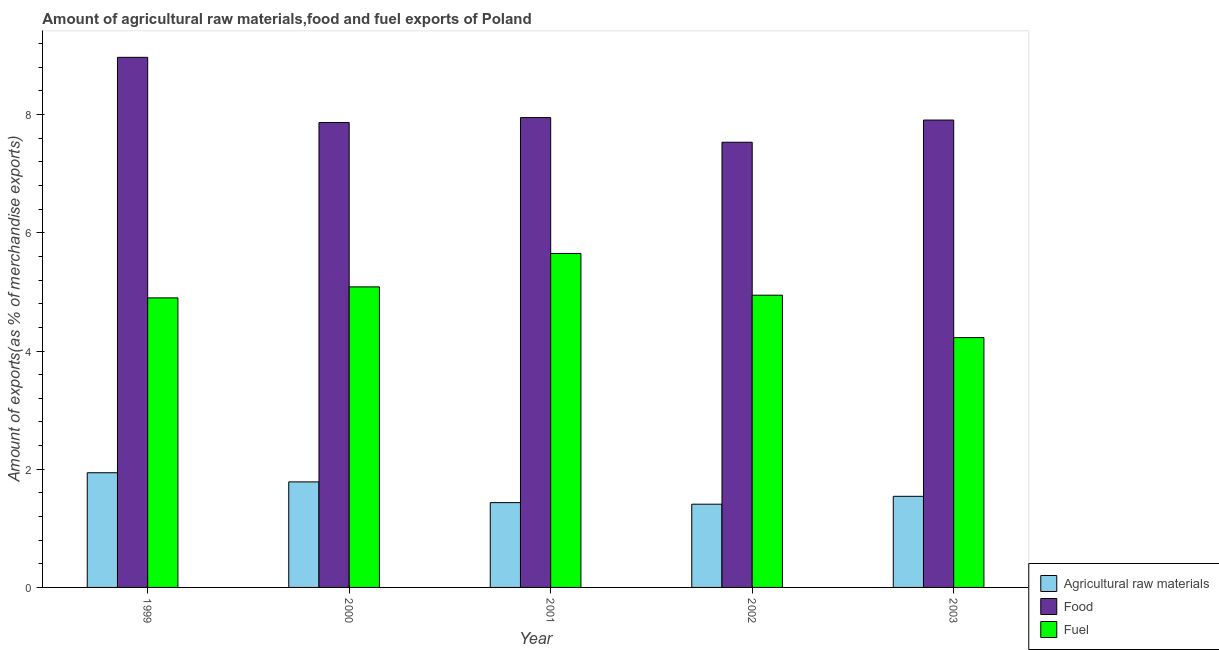How many different coloured bars are there?
Offer a terse response. 3. How many groups of bars are there?
Keep it short and to the point. 5. How many bars are there on the 3rd tick from the right?
Provide a succinct answer. 3. What is the label of the 5th group of bars from the left?
Provide a short and direct response. 2003. In how many cases, is the number of bars for a given year not equal to the number of legend labels?
Provide a succinct answer. 0. What is the percentage of fuel exports in 2000?
Give a very brief answer. 5.09. Across all years, what is the maximum percentage of fuel exports?
Keep it short and to the point. 5.65. Across all years, what is the minimum percentage of food exports?
Ensure brevity in your answer.  7.53. In which year was the percentage of raw materials exports minimum?
Provide a short and direct response. 2002. What is the total percentage of raw materials exports in the graph?
Make the answer very short. 8.11. What is the difference between the percentage of raw materials exports in 1999 and that in 2003?
Your response must be concise. 0.4. What is the difference between the percentage of raw materials exports in 1999 and the percentage of fuel exports in 2003?
Your answer should be compact. 0.4. What is the average percentage of raw materials exports per year?
Keep it short and to the point. 1.62. In the year 2003, what is the difference between the percentage of raw materials exports and percentage of fuel exports?
Your answer should be very brief. 0. In how many years, is the percentage of raw materials exports greater than 0.8 %?
Make the answer very short. 5. What is the ratio of the percentage of raw materials exports in 2001 to that in 2003?
Keep it short and to the point. 0.93. What is the difference between the highest and the second highest percentage of raw materials exports?
Offer a terse response. 0.15. What is the difference between the highest and the lowest percentage of raw materials exports?
Provide a succinct answer. 0.53. Is the sum of the percentage of raw materials exports in 2000 and 2003 greater than the maximum percentage of food exports across all years?
Your answer should be very brief. Yes. What does the 3rd bar from the left in 2000 represents?
Provide a short and direct response. Fuel. What does the 2nd bar from the right in 2002 represents?
Your answer should be compact. Food. Is it the case that in every year, the sum of the percentage of raw materials exports and percentage of food exports is greater than the percentage of fuel exports?
Your answer should be very brief. Yes. How many bars are there?
Give a very brief answer. 15. Does the graph contain grids?
Keep it short and to the point. No. How many legend labels are there?
Your answer should be compact. 3. What is the title of the graph?
Provide a short and direct response. Amount of agricultural raw materials,food and fuel exports of Poland. Does "Capital account" appear as one of the legend labels in the graph?
Keep it short and to the point. No. What is the label or title of the Y-axis?
Offer a terse response. Amount of exports(as % of merchandise exports). What is the Amount of exports(as % of merchandise exports) in Agricultural raw materials in 1999?
Your response must be concise. 1.94. What is the Amount of exports(as % of merchandise exports) of Food in 1999?
Provide a succinct answer. 8.97. What is the Amount of exports(as % of merchandise exports) of Fuel in 1999?
Keep it short and to the point. 4.9. What is the Amount of exports(as % of merchandise exports) in Agricultural raw materials in 2000?
Ensure brevity in your answer.  1.79. What is the Amount of exports(as % of merchandise exports) of Food in 2000?
Give a very brief answer. 7.87. What is the Amount of exports(as % of merchandise exports) in Fuel in 2000?
Offer a terse response. 5.09. What is the Amount of exports(as % of merchandise exports) of Agricultural raw materials in 2001?
Provide a succinct answer. 1.43. What is the Amount of exports(as % of merchandise exports) of Food in 2001?
Your answer should be compact. 7.95. What is the Amount of exports(as % of merchandise exports) of Fuel in 2001?
Ensure brevity in your answer.  5.65. What is the Amount of exports(as % of merchandise exports) of Agricultural raw materials in 2002?
Your answer should be compact. 1.41. What is the Amount of exports(as % of merchandise exports) in Food in 2002?
Your answer should be compact. 7.53. What is the Amount of exports(as % of merchandise exports) in Fuel in 2002?
Your answer should be very brief. 4.94. What is the Amount of exports(as % of merchandise exports) in Agricultural raw materials in 2003?
Offer a very short reply. 1.54. What is the Amount of exports(as % of merchandise exports) in Food in 2003?
Offer a very short reply. 7.91. What is the Amount of exports(as % of merchandise exports) in Fuel in 2003?
Keep it short and to the point. 4.23. Across all years, what is the maximum Amount of exports(as % of merchandise exports) in Agricultural raw materials?
Keep it short and to the point. 1.94. Across all years, what is the maximum Amount of exports(as % of merchandise exports) in Food?
Make the answer very short. 8.97. Across all years, what is the maximum Amount of exports(as % of merchandise exports) of Fuel?
Offer a terse response. 5.65. Across all years, what is the minimum Amount of exports(as % of merchandise exports) in Agricultural raw materials?
Offer a very short reply. 1.41. Across all years, what is the minimum Amount of exports(as % of merchandise exports) of Food?
Provide a short and direct response. 7.53. Across all years, what is the minimum Amount of exports(as % of merchandise exports) in Fuel?
Provide a short and direct response. 4.23. What is the total Amount of exports(as % of merchandise exports) in Agricultural raw materials in the graph?
Keep it short and to the point. 8.11. What is the total Amount of exports(as % of merchandise exports) of Food in the graph?
Give a very brief answer. 40.22. What is the total Amount of exports(as % of merchandise exports) in Fuel in the graph?
Make the answer very short. 24.81. What is the difference between the Amount of exports(as % of merchandise exports) of Agricultural raw materials in 1999 and that in 2000?
Provide a short and direct response. 0.15. What is the difference between the Amount of exports(as % of merchandise exports) in Food in 1999 and that in 2000?
Offer a terse response. 1.1. What is the difference between the Amount of exports(as % of merchandise exports) of Fuel in 1999 and that in 2000?
Provide a succinct answer. -0.19. What is the difference between the Amount of exports(as % of merchandise exports) in Agricultural raw materials in 1999 and that in 2001?
Your answer should be compact. 0.51. What is the difference between the Amount of exports(as % of merchandise exports) of Food in 1999 and that in 2001?
Keep it short and to the point. 1.02. What is the difference between the Amount of exports(as % of merchandise exports) in Fuel in 1999 and that in 2001?
Ensure brevity in your answer.  -0.75. What is the difference between the Amount of exports(as % of merchandise exports) in Agricultural raw materials in 1999 and that in 2002?
Ensure brevity in your answer.  0.53. What is the difference between the Amount of exports(as % of merchandise exports) in Food in 1999 and that in 2002?
Your answer should be very brief. 1.44. What is the difference between the Amount of exports(as % of merchandise exports) of Fuel in 1999 and that in 2002?
Give a very brief answer. -0.05. What is the difference between the Amount of exports(as % of merchandise exports) in Agricultural raw materials in 1999 and that in 2003?
Offer a terse response. 0.4. What is the difference between the Amount of exports(as % of merchandise exports) of Food in 1999 and that in 2003?
Keep it short and to the point. 1.06. What is the difference between the Amount of exports(as % of merchandise exports) in Fuel in 1999 and that in 2003?
Your answer should be compact. 0.67. What is the difference between the Amount of exports(as % of merchandise exports) of Agricultural raw materials in 2000 and that in 2001?
Your response must be concise. 0.35. What is the difference between the Amount of exports(as % of merchandise exports) of Food in 2000 and that in 2001?
Your response must be concise. -0.08. What is the difference between the Amount of exports(as % of merchandise exports) of Fuel in 2000 and that in 2001?
Provide a short and direct response. -0.57. What is the difference between the Amount of exports(as % of merchandise exports) of Agricultural raw materials in 2000 and that in 2002?
Keep it short and to the point. 0.38. What is the difference between the Amount of exports(as % of merchandise exports) of Food in 2000 and that in 2002?
Offer a terse response. 0.33. What is the difference between the Amount of exports(as % of merchandise exports) in Fuel in 2000 and that in 2002?
Offer a very short reply. 0.14. What is the difference between the Amount of exports(as % of merchandise exports) in Agricultural raw materials in 2000 and that in 2003?
Offer a very short reply. 0.24. What is the difference between the Amount of exports(as % of merchandise exports) of Food in 2000 and that in 2003?
Your answer should be compact. -0.04. What is the difference between the Amount of exports(as % of merchandise exports) in Fuel in 2000 and that in 2003?
Provide a short and direct response. 0.86. What is the difference between the Amount of exports(as % of merchandise exports) in Agricultural raw materials in 2001 and that in 2002?
Offer a very short reply. 0.03. What is the difference between the Amount of exports(as % of merchandise exports) of Food in 2001 and that in 2002?
Give a very brief answer. 0.42. What is the difference between the Amount of exports(as % of merchandise exports) in Fuel in 2001 and that in 2002?
Your answer should be very brief. 0.71. What is the difference between the Amount of exports(as % of merchandise exports) in Agricultural raw materials in 2001 and that in 2003?
Your answer should be very brief. -0.11. What is the difference between the Amount of exports(as % of merchandise exports) of Food in 2001 and that in 2003?
Your answer should be compact. 0.04. What is the difference between the Amount of exports(as % of merchandise exports) in Fuel in 2001 and that in 2003?
Ensure brevity in your answer.  1.42. What is the difference between the Amount of exports(as % of merchandise exports) of Agricultural raw materials in 2002 and that in 2003?
Offer a very short reply. -0.13. What is the difference between the Amount of exports(as % of merchandise exports) in Food in 2002 and that in 2003?
Your answer should be compact. -0.38. What is the difference between the Amount of exports(as % of merchandise exports) in Fuel in 2002 and that in 2003?
Your response must be concise. 0.72. What is the difference between the Amount of exports(as % of merchandise exports) in Agricultural raw materials in 1999 and the Amount of exports(as % of merchandise exports) in Food in 2000?
Keep it short and to the point. -5.93. What is the difference between the Amount of exports(as % of merchandise exports) in Agricultural raw materials in 1999 and the Amount of exports(as % of merchandise exports) in Fuel in 2000?
Offer a very short reply. -3.14. What is the difference between the Amount of exports(as % of merchandise exports) in Food in 1999 and the Amount of exports(as % of merchandise exports) in Fuel in 2000?
Give a very brief answer. 3.88. What is the difference between the Amount of exports(as % of merchandise exports) in Agricultural raw materials in 1999 and the Amount of exports(as % of merchandise exports) in Food in 2001?
Ensure brevity in your answer.  -6.01. What is the difference between the Amount of exports(as % of merchandise exports) of Agricultural raw materials in 1999 and the Amount of exports(as % of merchandise exports) of Fuel in 2001?
Offer a terse response. -3.71. What is the difference between the Amount of exports(as % of merchandise exports) of Food in 1999 and the Amount of exports(as % of merchandise exports) of Fuel in 2001?
Make the answer very short. 3.32. What is the difference between the Amount of exports(as % of merchandise exports) in Agricultural raw materials in 1999 and the Amount of exports(as % of merchandise exports) in Food in 2002?
Ensure brevity in your answer.  -5.59. What is the difference between the Amount of exports(as % of merchandise exports) in Agricultural raw materials in 1999 and the Amount of exports(as % of merchandise exports) in Fuel in 2002?
Your answer should be very brief. -3. What is the difference between the Amount of exports(as % of merchandise exports) of Food in 1999 and the Amount of exports(as % of merchandise exports) of Fuel in 2002?
Offer a terse response. 4.02. What is the difference between the Amount of exports(as % of merchandise exports) in Agricultural raw materials in 1999 and the Amount of exports(as % of merchandise exports) in Food in 2003?
Keep it short and to the point. -5.97. What is the difference between the Amount of exports(as % of merchandise exports) of Agricultural raw materials in 1999 and the Amount of exports(as % of merchandise exports) of Fuel in 2003?
Ensure brevity in your answer.  -2.29. What is the difference between the Amount of exports(as % of merchandise exports) of Food in 1999 and the Amount of exports(as % of merchandise exports) of Fuel in 2003?
Offer a very short reply. 4.74. What is the difference between the Amount of exports(as % of merchandise exports) of Agricultural raw materials in 2000 and the Amount of exports(as % of merchandise exports) of Food in 2001?
Ensure brevity in your answer.  -6.16. What is the difference between the Amount of exports(as % of merchandise exports) of Agricultural raw materials in 2000 and the Amount of exports(as % of merchandise exports) of Fuel in 2001?
Make the answer very short. -3.87. What is the difference between the Amount of exports(as % of merchandise exports) of Food in 2000 and the Amount of exports(as % of merchandise exports) of Fuel in 2001?
Provide a succinct answer. 2.21. What is the difference between the Amount of exports(as % of merchandise exports) of Agricultural raw materials in 2000 and the Amount of exports(as % of merchandise exports) of Food in 2002?
Offer a terse response. -5.75. What is the difference between the Amount of exports(as % of merchandise exports) in Agricultural raw materials in 2000 and the Amount of exports(as % of merchandise exports) in Fuel in 2002?
Your answer should be very brief. -3.16. What is the difference between the Amount of exports(as % of merchandise exports) of Food in 2000 and the Amount of exports(as % of merchandise exports) of Fuel in 2002?
Provide a succinct answer. 2.92. What is the difference between the Amount of exports(as % of merchandise exports) of Agricultural raw materials in 2000 and the Amount of exports(as % of merchandise exports) of Food in 2003?
Give a very brief answer. -6.12. What is the difference between the Amount of exports(as % of merchandise exports) in Agricultural raw materials in 2000 and the Amount of exports(as % of merchandise exports) in Fuel in 2003?
Your answer should be very brief. -2.44. What is the difference between the Amount of exports(as % of merchandise exports) of Food in 2000 and the Amount of exports(as % of merchandise exports) of Fuel in 2003?
Your answer should be compact. 3.64. What is the difference between the Amount of exports(as % of merchandise exports) of Agricultural raw materials in 2001 and the Amount of exports(as % of merchandise exports) of Food in 2002?
Offer a very short reply. -6.1. What is the difference between the Amount of exports(as % of merchandise exports) in Agricultural raw materials in 2001 and the Amount of exports(as % of merchandise exports) in Fuel in 2002?
Ensure brevity in your answer.  -3.51. What is the difference between the Amount of exports(as % of merchandise exports) of Food in 2001 and the Amount of exports(as % of merchandise exports) of Fuel in 2002?
Give a very brief answer. 3. What is the difference between the Amount of exports(as % of merchandise exports) in Agricultural raw materials in 2001 and the Amount of exports(as % of merchandise exports) in Food in 2003?
Make the answer very short. -6.47. What is the difference between the Amount of exports(as % of merchandise exports) of Agricultural raw materials in 2001 and the Amount of exports(as % of merchandise exports) of Fuel in 2003?
Your answer should be very brief. -2.79. What is the difference between the Amount of exports(as % of merchandise exports) of Food in 2001 and the Amount of exports(as % of merchandise exports) of Fuel in 2003?
Provide a succinct answer. 3.72. What is the difference between the Amount of exports(as % of merchandise exports) of Agricultural raw materials in 2002 and the Amount of exports(as % of merchandise exports) of Food in 2003?
Ensure brevity in your answer.  -6.5. What is the difference between the Amount of exports(as % of merchandise exports) in Agricultural raw materials in 2002 and the Amount of exports(as % of merchandise exports) in Fuel in 2003?
Offer a very short reply. -2.82. What is the difference between the Amount of exports(as % of merchandise exports) in Food in 2002 and the Amount of exports(as % of merchandise exports) in Fuel in 2003?
Give a very brief answer. 3.31. What is the average Amount of exports(as % of merchandise exports) of Agricultural raw materials per year?
Provide a succinct answer. 1.62. What is the average Amount of exports(as % of merchandise exports) in Food per year?
Your answer should be very brief. 8.04. What is the average Amount of exports(as % of merchandise exports) of Fuel per year?
Make the answer very short. 4.96. In the year 1999, what is the difference between the Amount of exports(as % of merchandise exports) in Agricultural raw materials and Amount of exports(as % of merchandise exports) in Food?
Provide a succinct answer. -7.03. In the year 1999, what is the difference between the Amount of exports(as % of merchandise exports) in Agricultural raw materials and Amount of exports(as % of merchandise exports) in Fuel?
Ensure brevity in your answer.  -2.96. In the year 1999, what is the difference between the Amount of exports(as % of merchandise exports) in Food and Amount of exports(as % of merchandise exports) in Fuel?
Keep it short and to the point. 4.07. In the year 2000, what is the difference between the Amount of exports(as % of merchandise exports) of Agricultural raw materials and Amount of exports(as % of merchandise exports) of Food?
Make the answer very short. -6.08. In the year 2000, what is the difference between the Amount of exports(as % of merchandise exports) of Agricultural raw materials and Amount of exports(as % of merchandise exports) of Fuel?
Provide a succinct answer. -3.3. In the year 2000, what is the difference between the Amount of exports(as % of merchandise exports) in Food and Amount of exports(as % of merchandise exports) in Fuel?
Your answer should be very brief. 2.78. In the year 2001, what is the difference between the Amount of exports(as % of merchandise exports) in Agricultural raw materials and Amount of exports(as % of merchandise exports) in Food?
Make the answer very short. -6.51. In the year 2001, what is the difference between the Amount of exports(as % of merchandise exports) of Agricultural raw materials and Amount of exports(as % of merchandise exports) of Fuel?
Your answer should be compact. -4.22. In the year 2001, what is the difference between the Amount of exports(as % of merchandise exports) of Food and Amount of exports(as % of merchandise exports) of Fuel?
Give a very brief answer. 2.3. In the year 2002, what is the difference between the Amount of exports(as % of merchandise exports) in Agricultural raw materials and Amount of exports(as % of merchandise exports) in Food?
Ensure brevity in your answer.  -6.12. In the year 2002, what is the difference between the Amount of exports(as % of merchandise exports) in Agricultural raw materials and Amount of exports(as % of merchandise exports) in Fuel?
Provide a short and direct response. -3.54. In the year 2002, what is the difference between the Amount of exports(as % of merchandise exports) in Food and Amount of exports(as % of merchandise exports) in Fuel?
Your answer should be very brief. 2.59. In the year 2003, what is the difference between the Amount of exports(as % of merchandise exports) in Agricultural raw materials and Amount of exports(as % of merchandise exports) in Food?
Your answer should be very brief. -6.37. In the year 2003, what is the difference between the Amount of exports(as % of merchandise exports) of Agricultural raw materials and Amount of exports(as % of merchandise exports) of Fuel?
Offer a very short reply. -2.69. In the year 2003, what is the difference between the Amount of exports(as % of merchandise exports) in Food and Amount of exports(as % of merchandise exports) in Fuel?
Offer a terse response. 3.68. What is the ratio of the Amount of exports(as % of merchandise exports) of Agricultural raw materials in 1999 to that in 2000?
Give a very brief answer. 1.09. What is the ratio of the Amount of exports(as % of merchandise exports) in Food in 1999 to that in 2000?
Offer a terse response. 1.14. What is the ratio of the Amount of exports(as % of merchandise exports) in Fuel in 1999 to that in 2000?
Provide a short and direct response. 0.96. What is the ratio of the Amount of exports(as % of merchandise exports) in Agricultural raw materials in 1999 to that in 2001?
Your answer should be very brief. 1.35. What is the ratio of the Amount of exports(as % of merchandise exports) of Food in 1999 to that in 2001?
Your response must be concise. 1.13. What is the ratio of the Amount of exports(as % of merchandise exports) of Fuel in 1999 to that in 2001?
Offer a very short reply. 0.87. What is the ratio of the Amount of exports(as % of merchandise exports) of Agricultural raw materials in 1999 to that in 2002?
Ensure brevity in your answer.  1.38. What is the ratio of the Amount of exports(as % of merchandise exports) in Food in 1999 to that in 2002?
Make the answer very short. 1.19. What is the ratio of the Amount of exports(as % of merchandise exports) in Fuel in 1999 to that in 2002?
Give a very brief answer. 0.99. What is the ratio of the Amount of exports(as % of merchandise exports) of Agricultural raw materials in 1999 to that in 2003?
Keep it short and to the point. 1.26. What is the ratio of the Amount of exports(as % of merchandise exports) of Food in 1999 to that in 2003?
Your answer should be compact. 1.13. What is the ratio of the Amount of exports(as % of merchandise exports) in Fuel in 1999 to that in 2003?
Keep it short and to the point. 1.16. What is the ratio of the Amount of exports(as % of merchandise exports) of Agricultural raw materials in 2000 to that in 2001?
Your response must be concise. 1.24. What is the ratio of the Amount of exports(as % of merchandise exports) in Fuel in 2000 to that in 2001?
Your response must be concise. 0.9. What is the ratio of the Amount of exports(as % of merchandise exports) of Agricultural raw materials in 2000 to that in 2002?
Provide a succinct answer. 1.27. What is the ratio of the Amount of exports(as % of merchandise exports) of Food in 2000 to that in 2002?
Provide a short and direct response. 1.04. What is the ratio of the Amount of exports(as % of merchandise exports) of Fuel in 2000 to that in 2002?
Your response must be concise. 1.03. What is the ratio of the Amount of exports(as % of merchandise exports) in Agricultural raw materials in 2000 to that in 2003?
Your response must be concise. 1.16. What is the ratio of the Amount of exports(as % of merchandise exports) of Food in 2000 to that in 2003?
Offer a terse response. 0.99. What is the ratio of the Amount of exports(as % of merchandise exports) in Fuel in 2000 to that in 2003?
Provide a succinct answer. 1.2. What is the ratio of the Amount of exports(as % of merchandise exports) in Agricultural raw materials in 2001 to that in 2002?
Your answer should be compact. 1.02. What is the ratio of the Amount of exports(as % of merchandise exports) in Food in 2001 to that in 2002?
Your response must be concise. 1.06. What is the ratio of the Amount of exports(as % of merchandise exports) in Agricultural raw materials in 2001 to that in 2003?
Offer a terse response. 0.93. What is the ratio of the Amount of exports(as % of merchandise exports) of Fuel in 2001 to that in 2003?
Provide a succinct answer. 1.34. What is the ratio of the Amount of exports(as % of merchandise exports) of Agricultural raw materials in 2002 to that in 2003?
Keep it short and to the point. 0.91. What is the ratio of the Amount of exports(as % of merchandise exports) of Food in 2002 to that in 2003?
Make the answer very short. 0.95. What is the ratio of the Amount of exports(as % of merchandise exports) of Fuel in 2002 to that in 2003?
Offer a very short reply. 1.17. What is the difference between the highest and the second highest Amount of exports(as % of merchandise exports) in Agricultural raw materials?
Your response must be concise. 0.15. What is the difference between the highest and the second highest Amount of exports(as % of merchandise exports) of Food?
Your answer should be compact. 1.02. What is the difference between the highest and the second highest Amount of exports(as % of merchandise exports) in Fuel?
Provide a short and direct response. 0.57. What is the difference between the highest and the lowest Amount of exports(as % of merchandise exports) in Agricultural raw materials?
Ensure brevity in your answer.  0.53. What is the difference between the highest and the lowest Amount of exports(as % of merchandise exports) in Food?
Make the answer very short. 1.44. What is the difference between the highest and the lowest Amount of exports(as % of merchandise exports) of Fuel?
Provide a succinct answer. 1.42. 